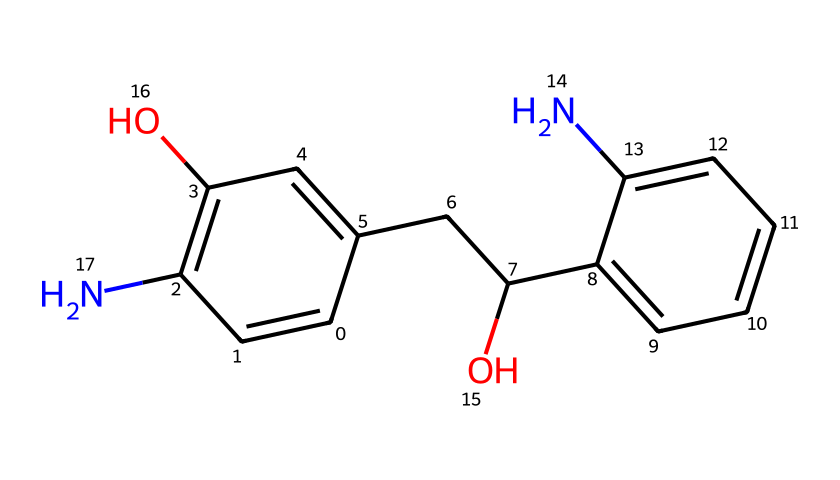What is the molecular formula of the drug? To find the molecular formula, count each type of atom present in the SMILES representation. The aromatic rings (C) and functional groups (O, N) can be tallied. In this case, there are 19 carbons, 21 hydrogens, 2 oxygens, and 1 nitrogen. Therefore, the molecular formula is C19H21N2O2.
Answer: C19H21N2O2 How many rings are present in the structure? Analyze the structure for cyclic components. There are two distinct aromatic rings identifiable in the chemical structure which means there are two closed loops in the molecule.
Answer: 2 What functional groups are present? Identify functional groups from the structure based on common characteristics. In this compound, the hydroxyl group (-OH) and an amine group (-NH) are evident, indicating presence of alcohol and amine functional groups respectively.
Answer: alcohol and amine What is the role of nitrogen in this chemical? The nitrogen atom in the structure is part of the amine group, which typically serves a vital role in pharmacodynamics such as receptor binding or enhancing solubility, thereby influencing the drug's activity.
Answer: receptor binding Why is this compound considered a drug? The presence of specific structural features, such as the nitrogen atom and functional groups that interact with biological receptors, qualifies this compound for therapeutic applications, specifically as a serotonin modulator.
Answer: serotonin modulator Which part of the molecule is likely responsible for its psychoactive effects? The presence of the aromatic rings with the nitrogen atom suggests that this portion can interact with serotonin receptors in the brain, influencing mood and behavior, indicative of psychoactive effects.
Answer: aromatic rings with nitrogen 